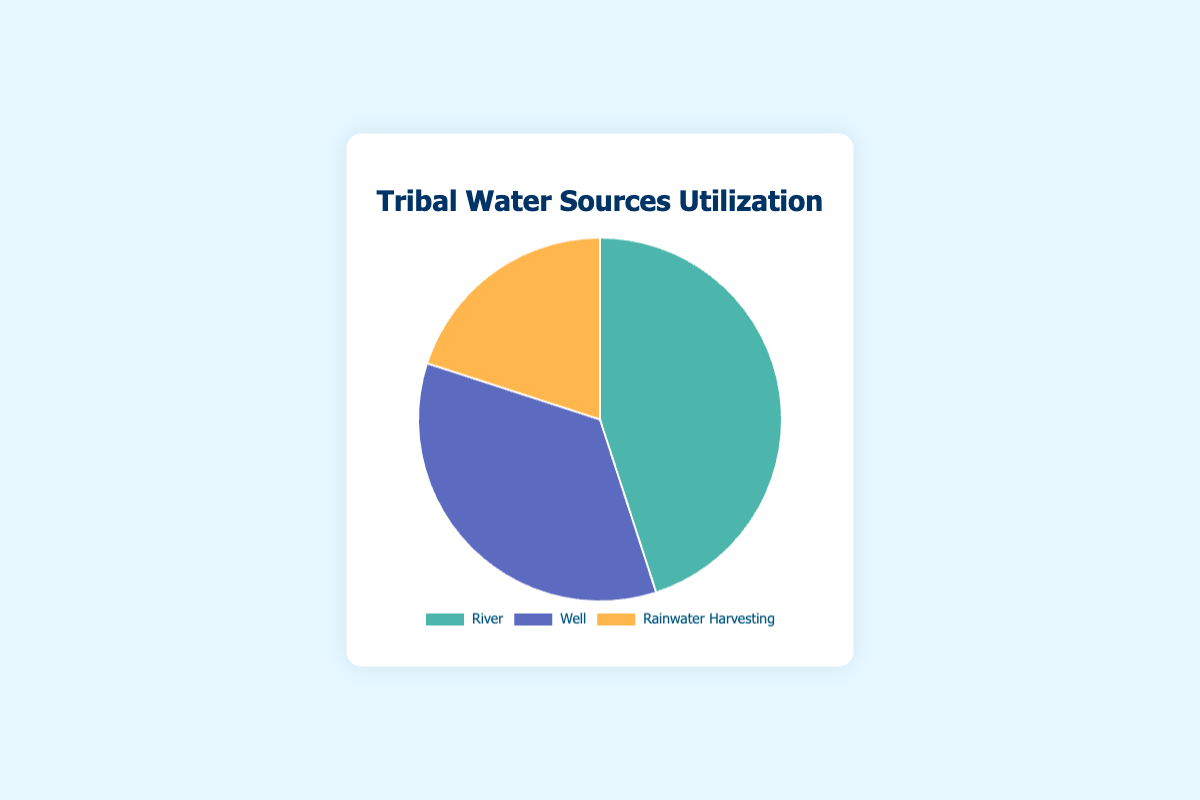How many types of water sources are represented in the chart? The chart includes categories for each type of water source. Count the different types listed in the legend and the labels of the chart.
Answer: 3 Which water source is utilized the most by the tribe? Look at the portions of the pie chart and identify which segment is the largest. This corresponds to the highest percentage of utilization.
Answer: River Which water source is utilized the least by the tribe? Examine the visual representation of the pie chart and look for the smallest segment. This segment indicates the water source with the lowest utilization percentage.
Answer: Rainwater Harvesting What is the combined utilization percentage of wells and rainwater harvesting? Add the utilization percentages of wells (35%) and rainwater harvesting (20%). Sum them to find the combined usage.
Answer: 55% How much higher is the utilization percentage of rivers compared to rainwater harvesting? Subtract the utilization percentage of rainwater harvesting (20%) from the utilization percentage of rivers (45%).
Answer: 25% Describe the color used for the segment representing wells. Look at the segment of the pie chart labeled wells and observe the visual color of the segment.
Answer: Blue If the tribe decided to increase the utilization of rainwater harvesting by 10%, what would the new utilization percentage be? Add 10% to the current utilization percentage of rainwater harvesting (20%). Calculate the new total.
Answer: 30% Compare the utilization percentages of wells and river. Which one is greater? By how much? Compare the percentages: River (45%) is greater than Well (35%). Subtract the smaller percentage from the larger to find the difference.
Answer: River, by 10% What is the average utilization percentage of all the water sources? Add the utilization percentages of river (45%), well (35%), and rainwater harvesting (20%), then divide by the number of sources (3).
Answer: 33.33% If rainwater harvesting's utilization were to double, would it surpass the well's utilization? Double the utilization percentage of rainwater harvesting (20% * 2 = 40%) and compare it to the well's percentage (35%).
Answer: Yes, it would surpass 